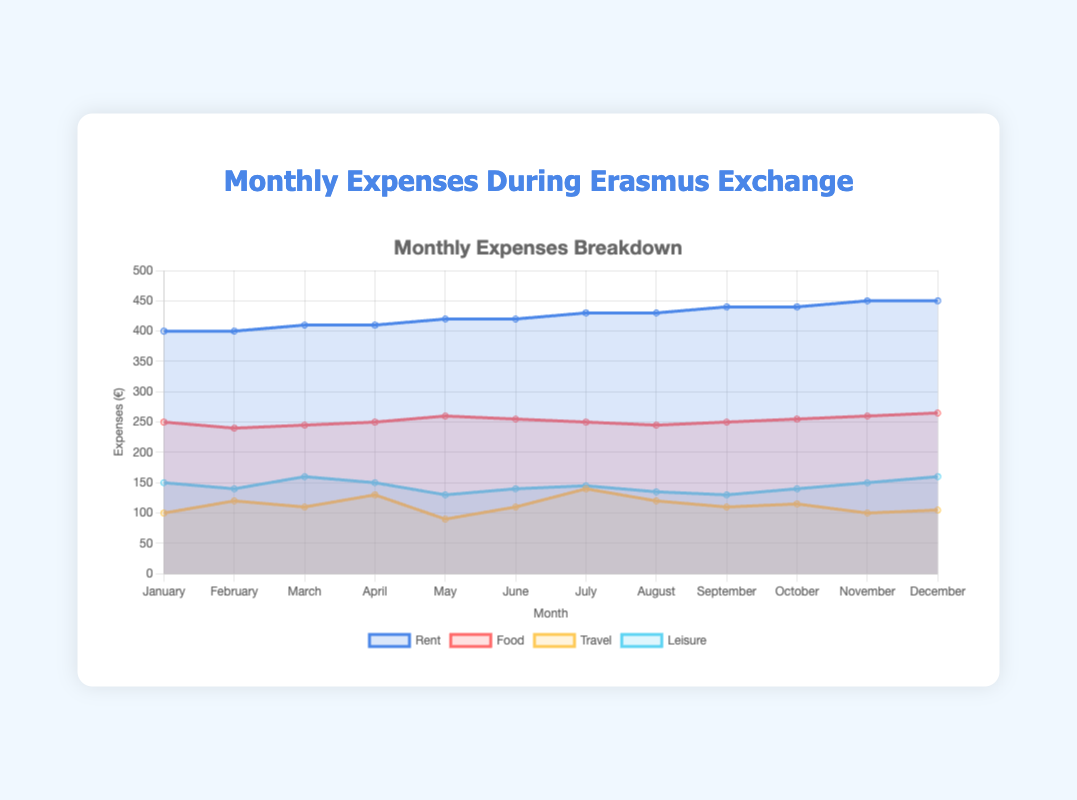What was the monthly expense on rent in October? Referring to the figure, the expense on rent in October is indicated by the blue line corresponding to October, which is €440.
Answer: €440 Which month had the highest food expense, and what was the amount? The highest point on the red line corresponds to December, where the food expense reaches €265.
Answer: December, €265 Compare travel expenses in February and May, which month had higher expenses? The yellow line indicates travel expenses. In May, the travel expense is €90, whereas in February, it is €120. Therefore, February has higher expenses.
Answer: February Calculate the average monthly expense on leisure from January to June. The leisure expenses from January to June are as follows: 150, 140, 160, 150, 130, 140. Summing these values gives 870, and the average over six months is 870/6 = 145.
Answer: €145 Which month had the lowest total expenses (sum of rent, food, travel, and leisure)? To find the lowest total expenses, sum the expenses for each category in each month and compare them. January (400+250+100+150 = 900), February (400+240+120+140 = 900), March (410+245+110+160 = 925), April (410+250+130+150 = 940), May (420+260+90+130 = 900), June (420+255+110+140 = 925). January, February, and May all have total expenses of €900. These are the lowest.
Answer: January, February, May How much did travel expenses change from March to April? The travel expenses for March and April, as shown by the yellow line, are 110 and 130 respectively. The change is 130 - 110 = 20 euros.
Answer: €20 What was the difference in food expenses between the start of the year (January) and the end of the year (December)? The food expense in January is €250, and in December, it is €265. The difference is 265 - 250 = 15 euros.
Answer: €15 Which month shows the highest fluctuation in expenses? The month with the highest fluctuation would be the one with the significant change in any category. Observing the lines clearly shows July as the month with spikes in travel and an increase in rent.
Answer: July 